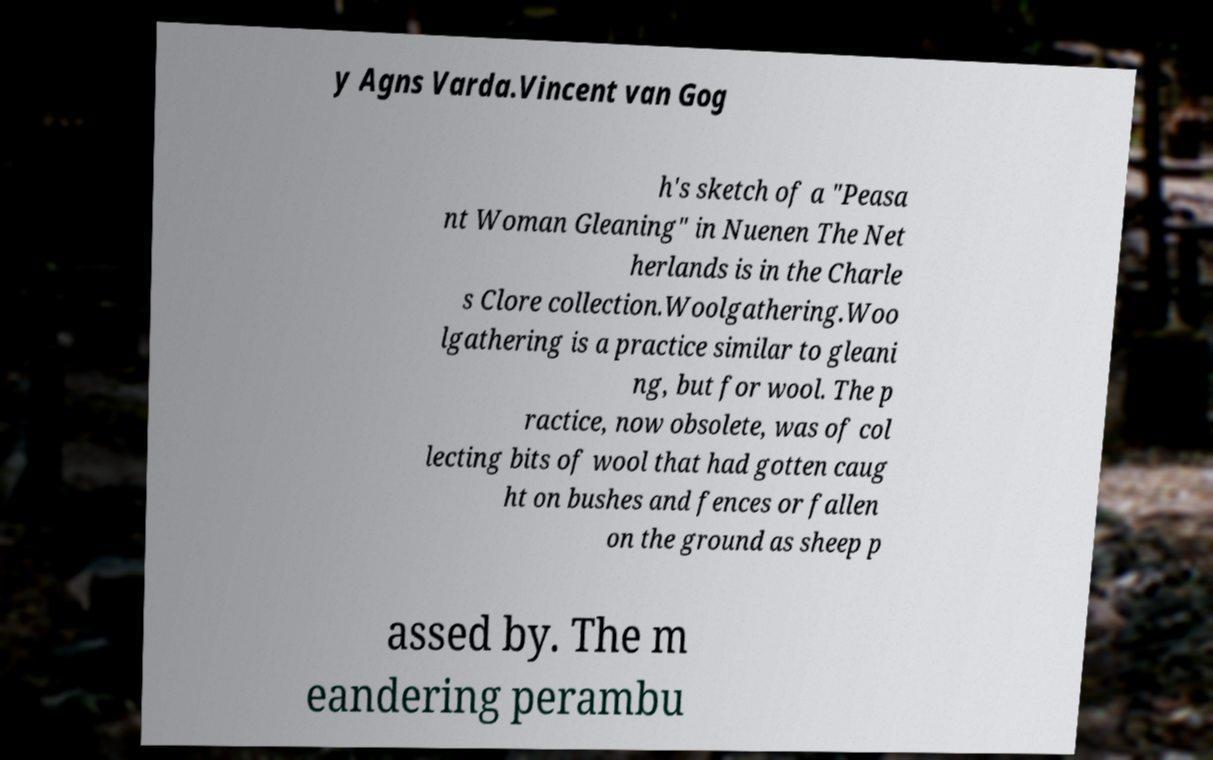What messages or text are displayed in this image? I need them in a readable, typed format. y Agns Varda.Vincent van Gog h's sketch of a "Peasa nt Woman Gleaning" in Nuenen The Net herlands is in the Charle s Clore collection.Woolgathering.Woo lgathering is a practice similar to gleani ng, but for wool. The p ractice, now obsolete, was of col lecting bits of wool that had gotten caug ht on bushes and fences or fallen on the ground as sheep p assed by. The m eandering perambu 